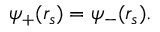<formula> <loc_0><loc_0><loc_500><loc_500>\psi _ { + } ( r _ { s } ) = \psi _ { - } ( r _ { s } ) .</formula> 